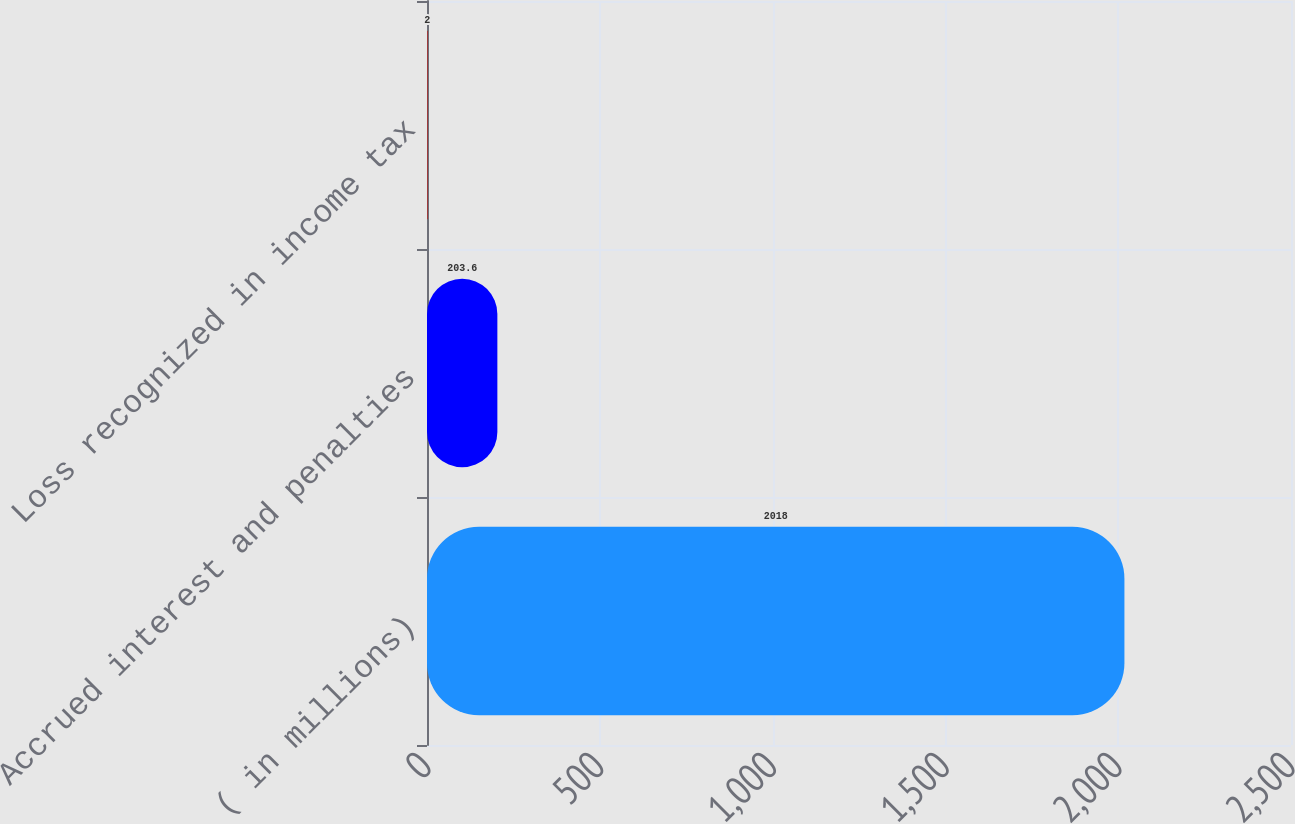Convert chart. <chart><loc_0><loc_0><loc_500><loc_500><bar_chart><fcel>( in millions)<fcel>Accrued interest and penalties<fcel>Loss recognized in income tax<nl><fcel>2018<fcel>203.6<fcel>2<nl></chart> 